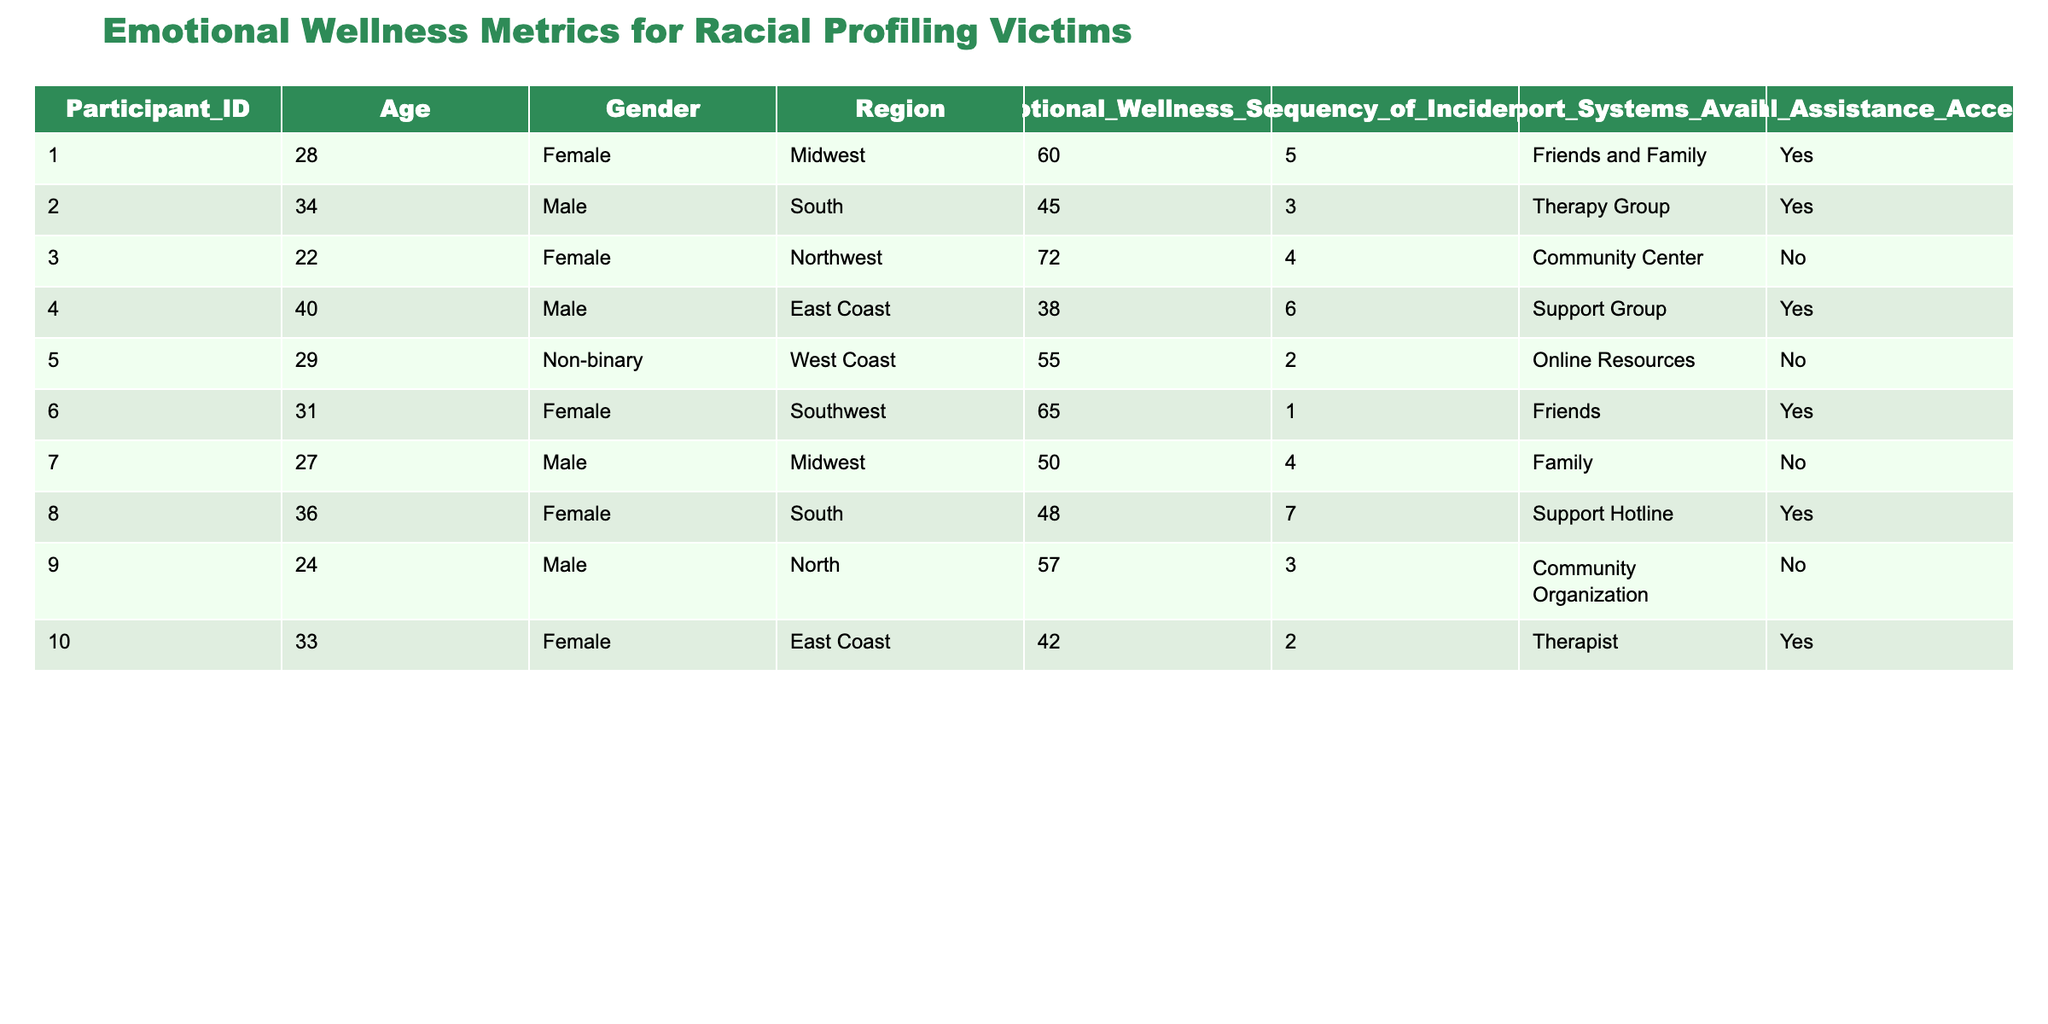What is the Emotional Wellness Score of the participant from the East Coast? The participant from the East Coast is identified by Participant_ID 4, whose Emotional Wellness Score is listed as 38.
Answer: 38 What is the frequency of incidents for the participant who accessed legal assistance but listed no support systems available? Examining the table, Participant_ID 5 accessed legal assistance and is marked with "Online Resources" as support systems available. Thus, no participant fits this description, meaning the question is invalid.
Answer: None (invalid question) What is the average Emotional Wellness Score for all participants? To calculate the average, we add up all Emotional Wellness Scores: (60 + 45 + 72 + 38 + 55 + 65 + 50 + 48 + 57 + 42) = 462. There are 10 participants, so the average Emotional Wellness Score is 462 / 10 = 46.2.
Answer: 46.2 Which participant has the highest Emotional Wellness Score and what is that score? Reviewing the scores, Participant_ID 3 has the highest score listed at 72. This is the highest among all participant scores recorded.
Answer: 72 How many participants reported having access to legal assistance? By filtering the table for the "Legal Assistance Accessed" column, we count those who have "Yes." There are 5 participants out of the total 10 who reported having accessed legal assistance.
Answer: 5 What is the emotional wellness score difference between the participant with the most incidents and the participant with the least? Participant_ID 8 has the most frequent incidents (7), and their Emotional Wellness Score is 48. Participant_ID 6 has the least incidents (1), with a score of 65. The difference in their scores is 65 - 48 = 17.
Answer: 17 Do more males or females have scores above 50? Among the participants, we count those who are male and have scores above 50: Participant 6 (65), Participant 3 (72), and Participant 1 (60) are females, while Participant 2 (45), Participant 4 (38), and Participant 9 (57) are males. Both male and female totals above 50 are equal, so 3 males and 3 females have scores above 50.
Answer: Equal (3 each) What region has the participant with the lowest emotional wellness score? Looking through the Emotional Wellness Scores, Participant_ID 4 from the East Coast has the lowest score of 38.
Answer: East Coast 